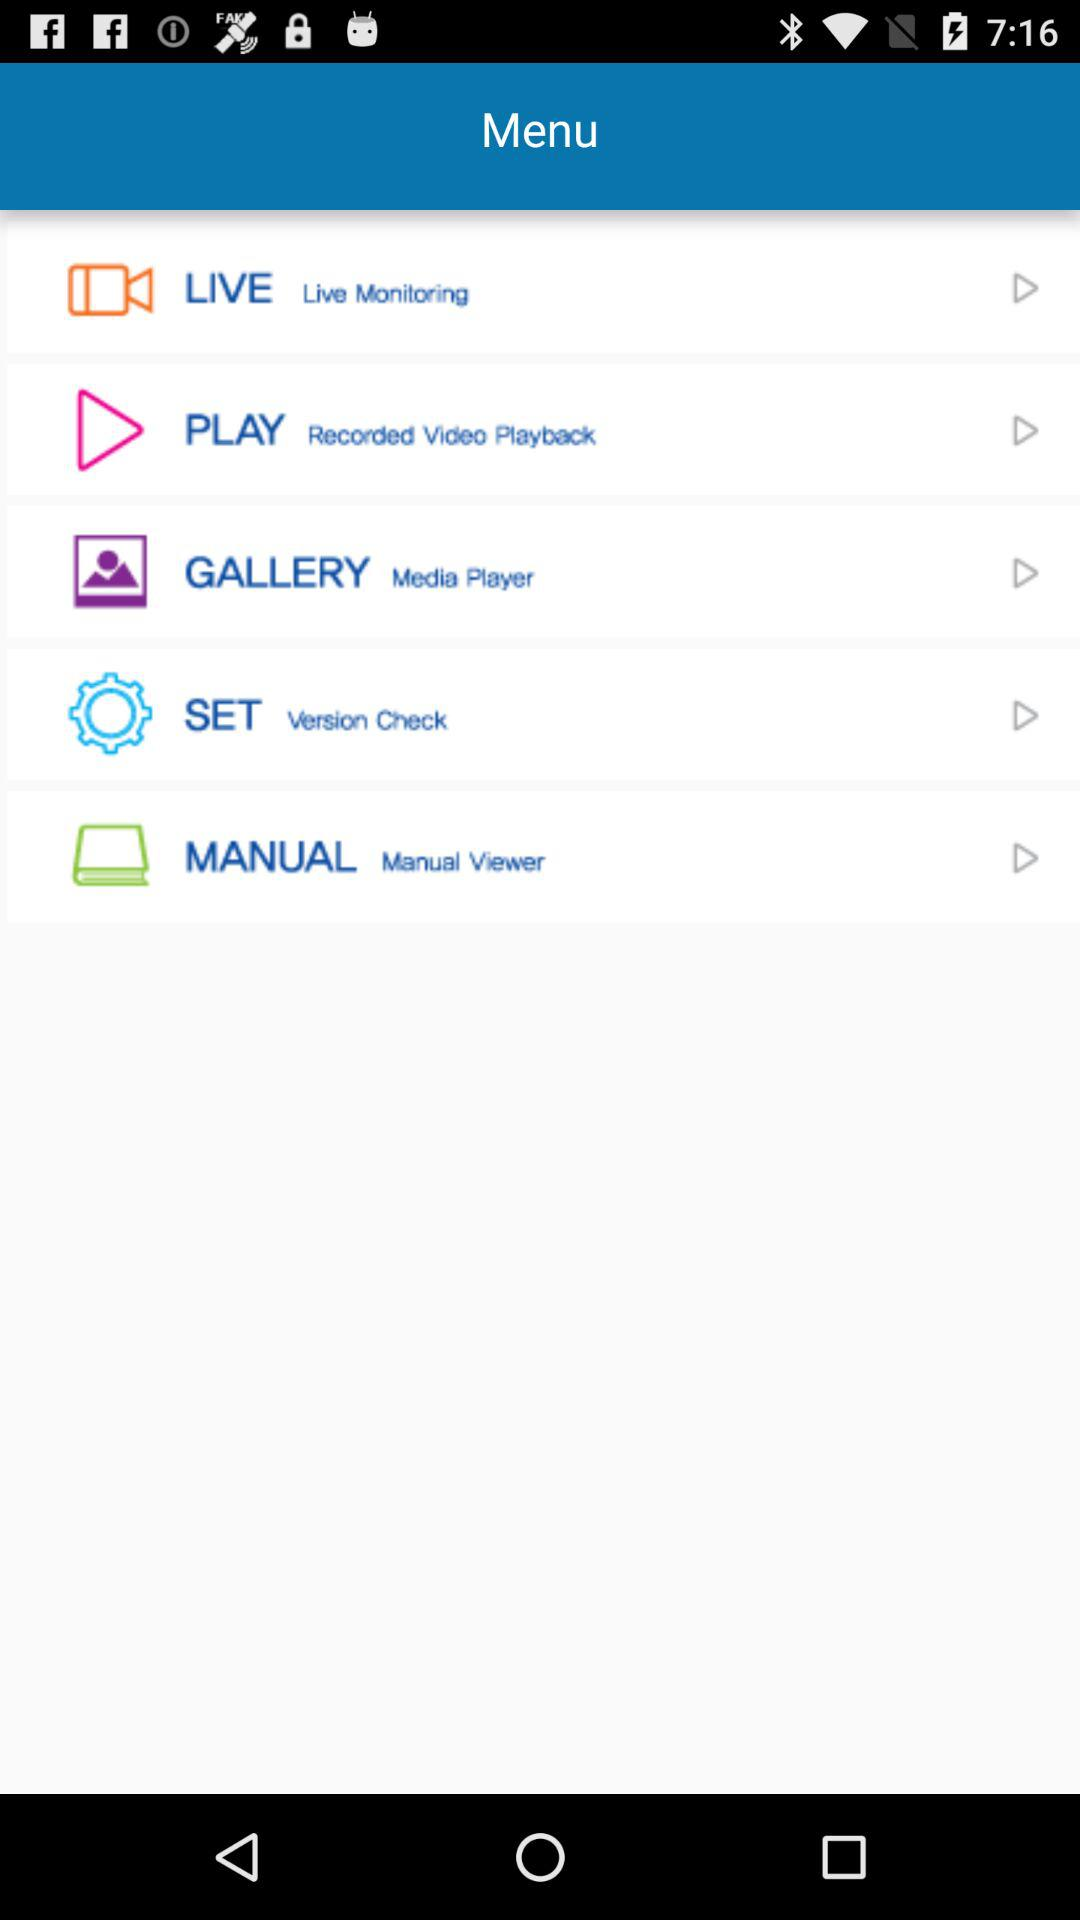How many items are in the menu?
Answer the question using a single word or phrase. 5 